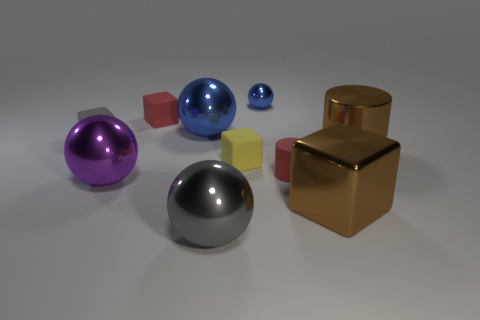There is a tiny object that is the same color as the small cylinder; what shape is it?
Your response must be concise. Cube. There is a brown thing in front of the small red matte object in front of the big blue metallic object; what is its size?
Ensure brevity in your answer.  Large. What number of cubes are tiny blue metallic objects or gray rubber objects?
Your answer should be compact. 1. The block that is the same size as the purple shiny sphere is what color?
Ensure brevity in your answer.  Brown. There is a small red object right of the matte object that is behind the big blue ball; what shape is it?
Your answer should be compact. Cylinder. There is a brown thing that is in front of the yellow rubber thing; is its size the same as the tiny yellow rubber object?
Provide a short and direct response. No. What number of other things are there of the same material as the yellow cube
Your answer should be very brief. 3. What number of blue things are either tiny things or large cylinders?
Provide a succinct answer. 1. There is a rubber thing that is the same color as the tiny cylinder; what is its size?
Provide a short and direct response. Small. What number of large blocks are on the right side of the big cylinder?
Ensure brevity in your answer.  0. 